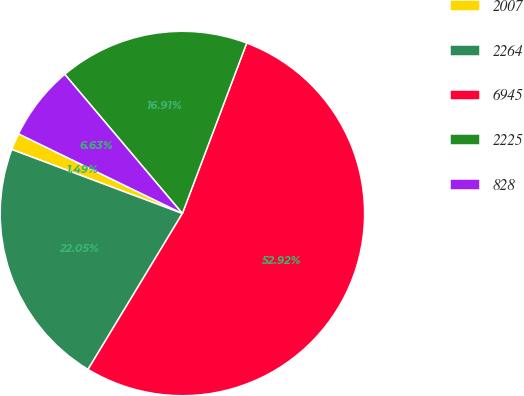<chart> <loc_0><loc_0><loc_500><loc_500><pie_chart><fcel>2007<fcel>2264<fcel>6945<fcel>2225<fcel>828<nl><fcel>1.49%<fcel>22.05%<fcel>52.92%<fcel>16.91%<fcel>6.63%<nl></chart> 